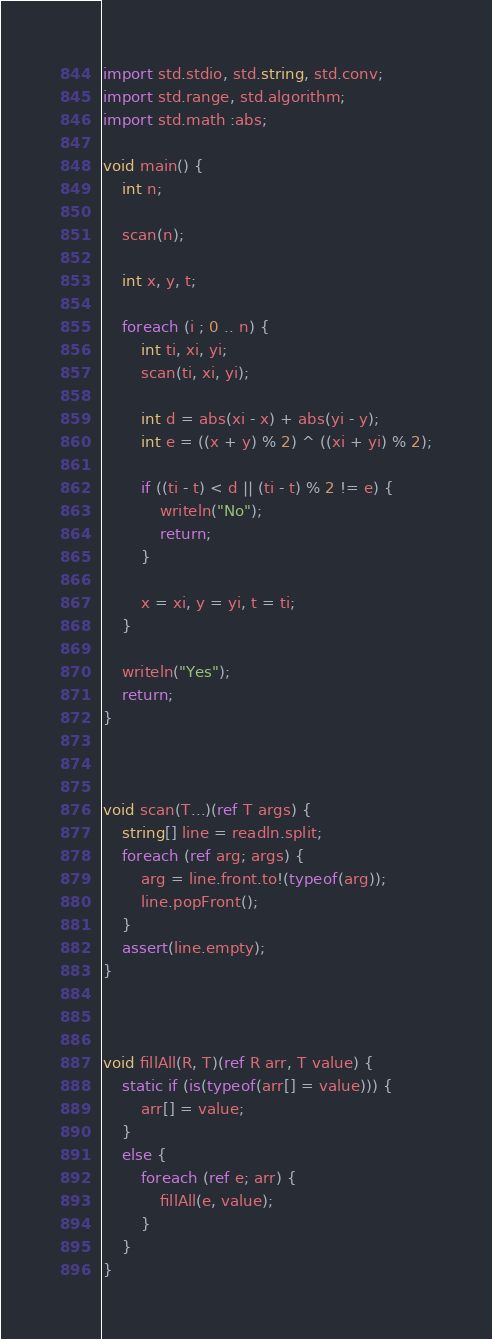<code> <loc_0><loc_0><loc_500><loc_500><_D_>import std.stdio, std.string, std.conv;
import std.range, std.algorithm;
import std.math :abs;

void main() {
    int n;

    scan(n);

    int x, y, t;

    foreach (i ; 0 .. n) {
        int ti, xi, yi;
        scan(ti, xi, yi);

        int d = abs(xi - x) + abs(yi - y);
        int e = ((x + y) % 2) ^ ((xi + yi) % 2);

        if ((ti - t) < d || (ti - t) % 2 != e) {
            writeln("No");
            return;
        }

        x = xi, y = yi, t = ti;
    }

    writeln("Yes");
    return;
}



void scan(T...)(ref T args) {
    string[] line = readln.split;
    foreach (ref arg; args) {
        arg = line.front.to!(typeof(arg));
        line.popFront();
    }
    assert(line.empty);
}



void fillAll(R, T)(ref R arr, T value) {
    static if (is(typeof(arr[] = value))) {
        arr[] = value;
    }
    else {
        foreach (ref e; arr) {
            fillAll(e, value);
        }
    }
}</code> 